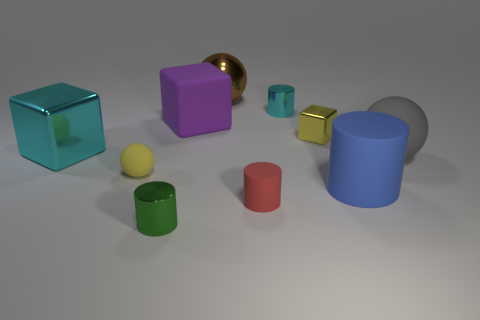Subtract all large cylinders. How many cylinders are left? 3 Subtract all red cylinders. How many cylinders are left? 3 Subtract 1 yellow spheres. How many objects are left? 9 Subtract all spheres. How many objects are left? 7 Subtract 4 cylinders. How many cylinders are left? 0 Subtract all cyan cylinders. Subtract all gray blocks. How many cylinders are left? 3 Subtract all green balls. How many cyan cubes are left? 1 Subtract all big green cylinders. Subtract all cyan shiny things. How many objects are left? 8 Add 8 tiny metal blocks. How many tiny metal blocks are left? 9 Add 8 large gray things. How many large gray things exist? 9 